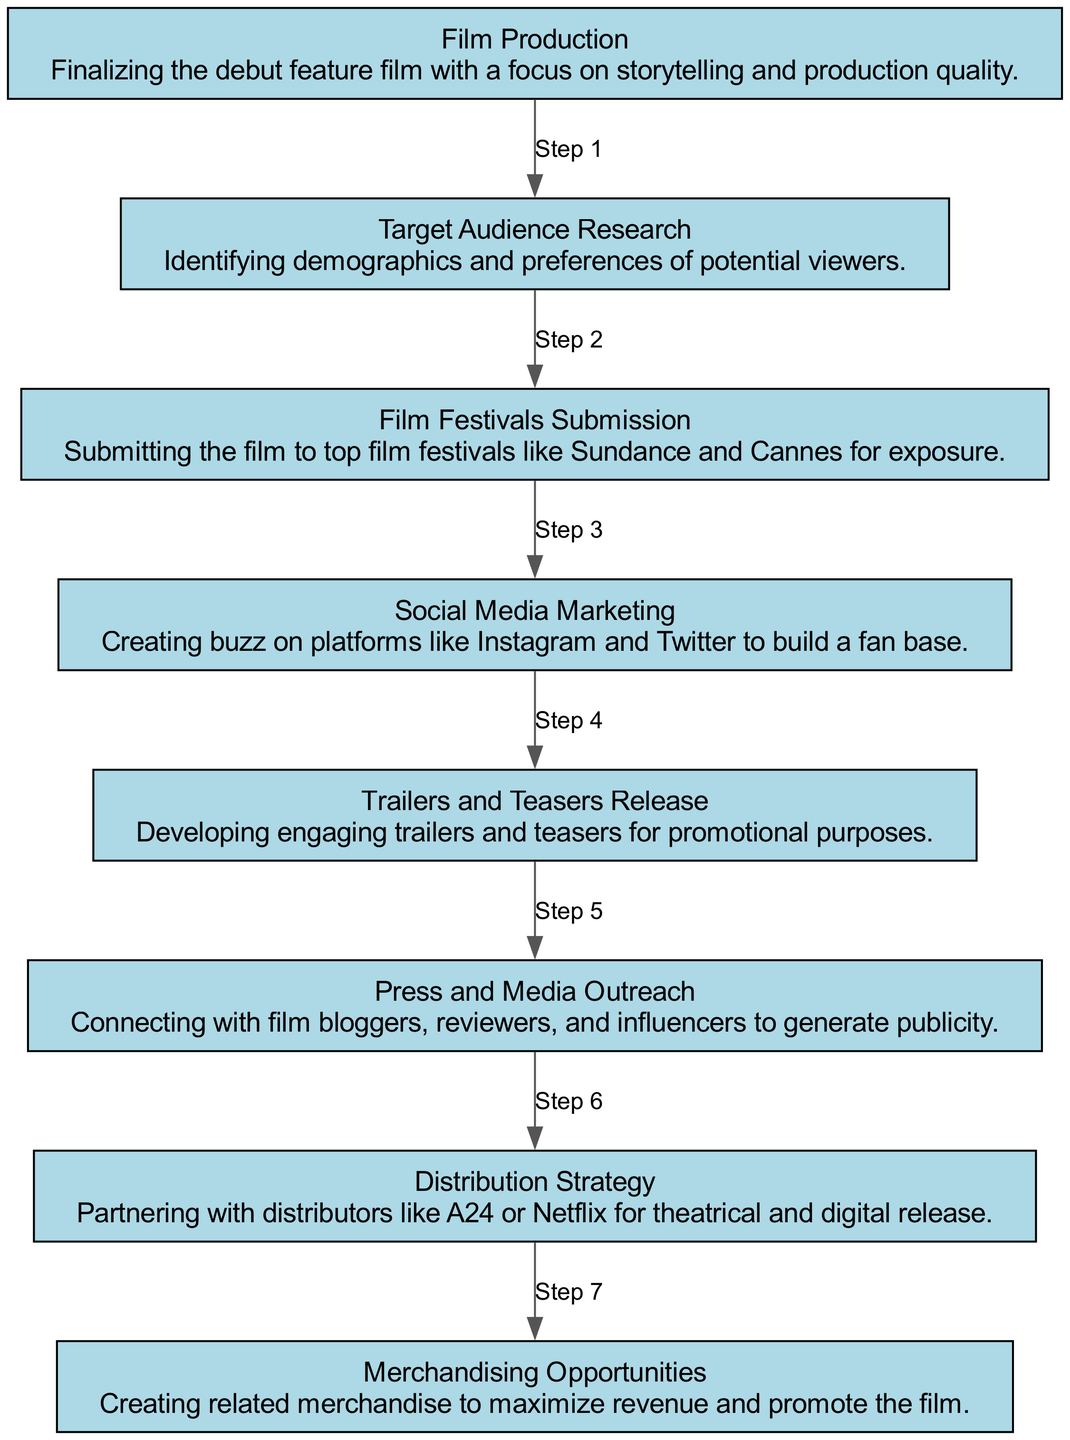What is the first step in the distribution and marketing strategy? The first step is "Film Production," where the focus is on finalizing the debut feature film with attention to storytelling and production quality.
Answer: Film Production How many total elements are there in the diagram? There are eight elements in the diagram, each representing a key component in the distribution and marketing strategy.
Answer: 8 What follows after "Target Audience Research"? After "Target Audience Research," the next step is "Film Festivals Submission," where the film is submitted to major festivals for exposure.
Answer: Film Festivals Submission Which element is associated with creating a fan base? "Social Media Marketing" is the element that focuses on creating a buzz on social media platforms to build a fan base.
Answer: Social Media Marketing What is the last step in the sequence? The last step is "Merchandising Opportunities," which involves creating merchandise related to the film to maximize revenue and promote it.
Answer: Merchandising Opportunities Which two elements form a direct connection in the diagram? "Trailers and Teasers Release" and "Press and Media Outreach" directly connect as they are sequential steps in promoting the film after it has been produced.
Answer: Trailers and Teasers Release, Press and Media Outreach What is the relationship between "Distribution Strategy" and "Film Festivals Submission"? "Distribution Strategy" comes after "Film Festivals Submission," indicating that the distribution partnerships are finalized after submitting the film to festivals.
Answer: Distribution Strategy What kind of outreach is emphasized in one of the steps? "Press and Media Outreach" emphasizes connecting with film bloggers, reviewers, and influencers to generate publicity for the film.
Answer: Press and Media Outreach 